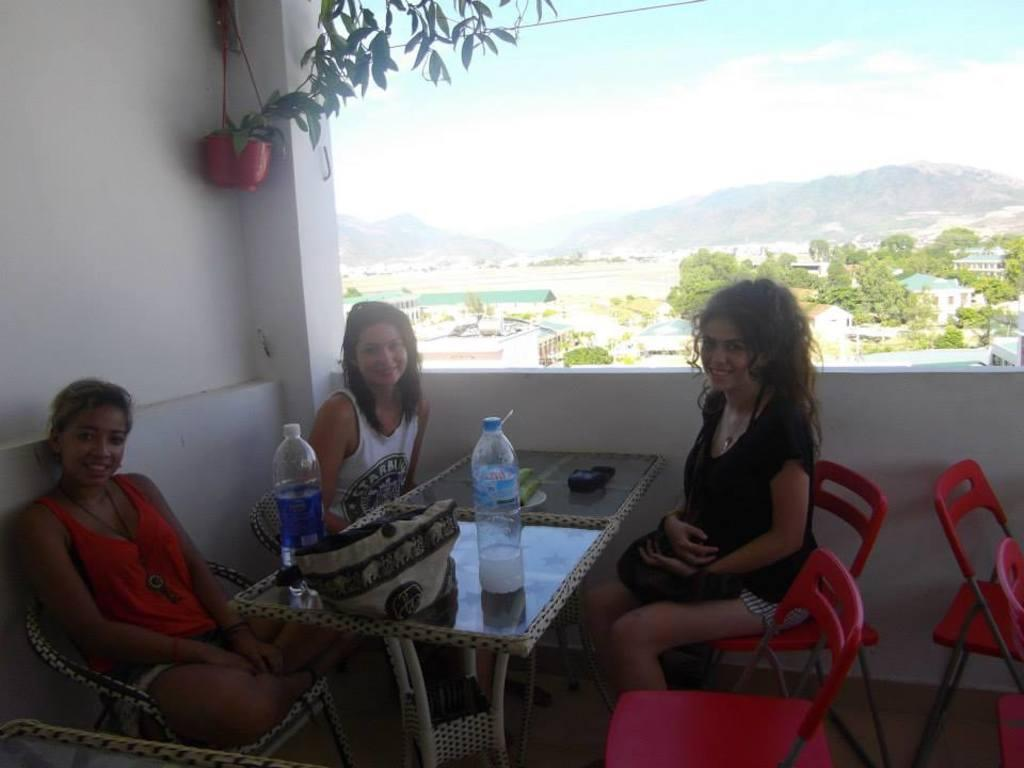What type of plant can be seen in the image? There is a plant in the image, but the specific type cannot be determined from the facts provided. What can be seen in the sky in the image? The sky is visible in the image, but no specific details about the sky are mentioned in the facts. What is the terrain feature in the image? There is a hill in the image. What type of vegetation is present in the image? Trees are present in the image. How many people are sitting in the image? There are three people sitting on chairs in the image. What is on the table in the image? There is a table in the image, and on it, there is a handbag and bottles. How many babies are crawling under the veil in the image? There is no veil or babies present in the image. What is the distance between the people sitting on chairs and the hill in the image? The facts provided do not give any information about the distance between the people and the hill in the image. 